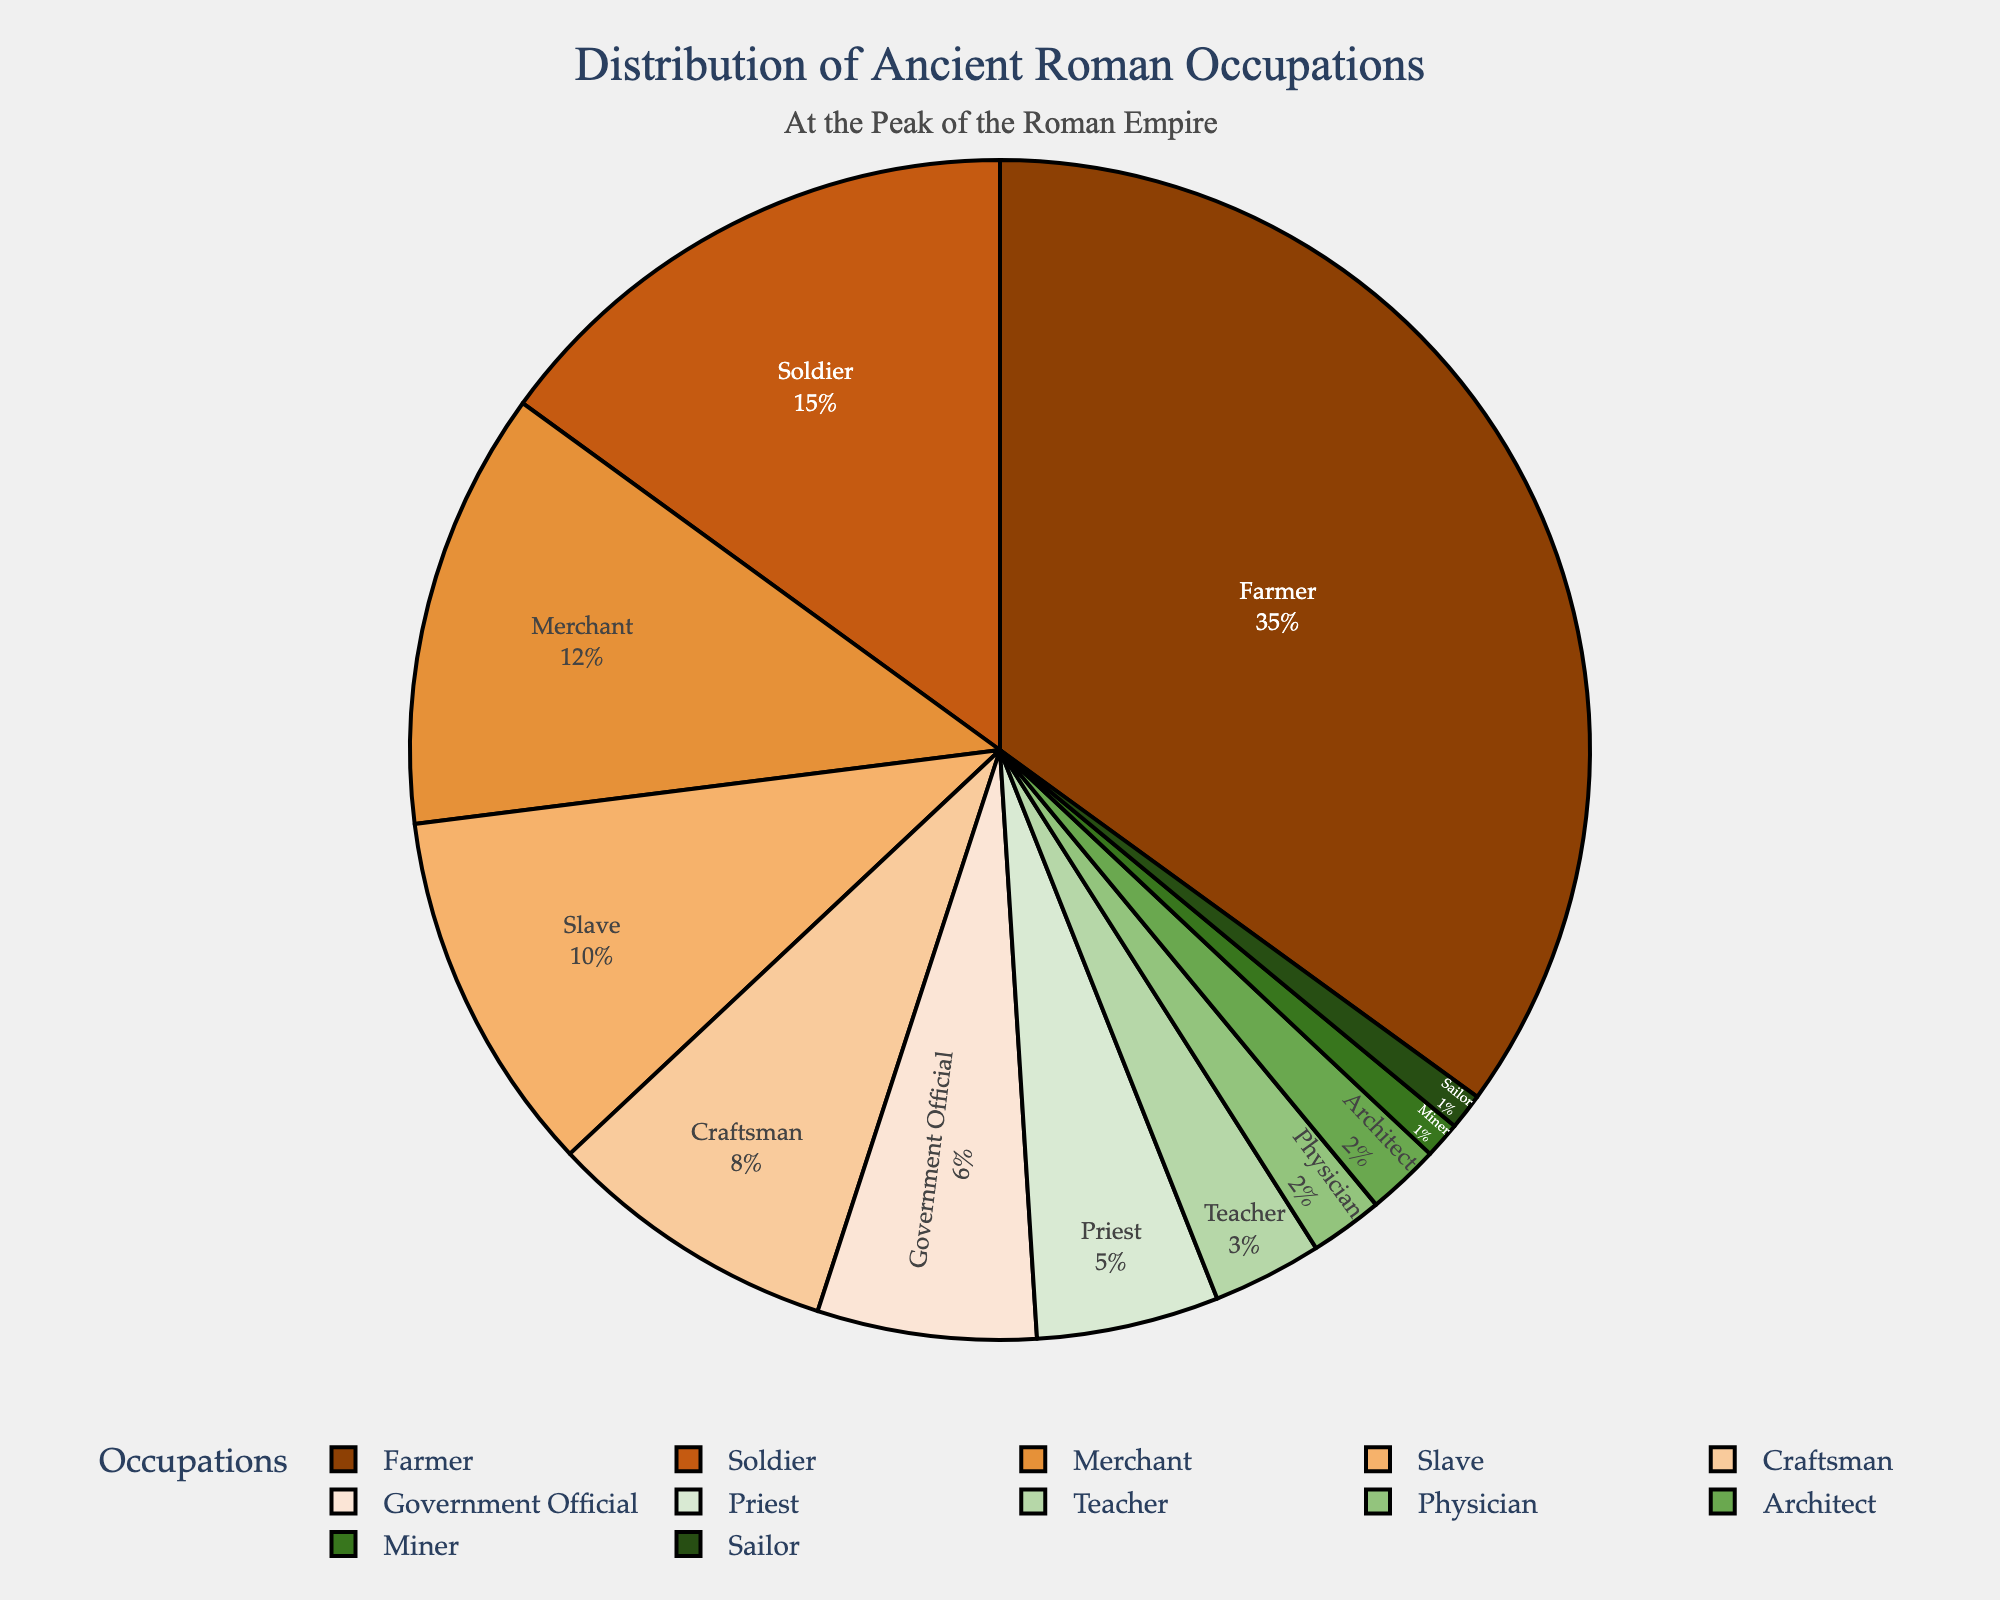What percentage of ancient Roman occupations were related to agriculture? By observing the pie chart, it's clear that "Farmer" occupies 35%, which is the only category directly related to agriculture.
Answer: 35% Which occupation was more common, Merchant or Government Official? By comparing the pie chart segments, the percentage of Merchants is 12% while Government Officials is 6%.
Answer: Merchant What is the combined percentage of Slaves, Craftsmen, and Priests? Add the percentages of Slaves (10%), Craftsmen (8%), and Priests (5%) together: 10 + 8 + 5 = 23%.
Answer: 23% How does the percentage of Soldiers compare to the percentage of Farmers? Soldiers occupy 15% of the pie chart, whereas Farmers occupy 35%. 15% is less than 35%.
Answer: Farmers have a higher percentage Is the percentage of Teachers greater than the combined percentage of Physicians and Architects? Teachers occupy 3% of the chart. Physicians and Architects together hold 2% + 2% = 4%. Thus, 3% is not greater than 4%.
Answer: No If you combine the percentages of Miners and Sailors, would their total be greater than Physicians? Miners are 1% and Sailors are 1%, combining to 1 + 1 = 2%. Physicians are also 2%, so they are equal.
Answer: Equal What occupation occupies the smallest segment on the pie chart? Both Miners and Sailors occupy the smallest segments, each having 1%.
Answer: Miners and Sailors Add the percentages of all occupations listed except Farmers. What is the resulting percentage? Subtract the Farmer percentage (35%) from the total 100%: 100 - 35 = 65%.
Answer: 65% Which occupation is twice as common as Government Officials? Government Officials occupy 6%. Twice this amount is 6 x 2 = 12%, which matches the percentage for Merchants.
Answer: Merchant What is the average percentage of the three least common occupations? The three least common occupations are Miner (1%), Sailor (1%), and Physician (2%). The average is (1 + 1 + 2) / 3 = 4 / 3 ≈ 1.33%.
Answer: Approximately 1.33% 